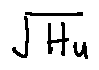<formula> <loc_0><loc_0><loc_500><loc_500>\sqrt { H _ { u } }</formula> 